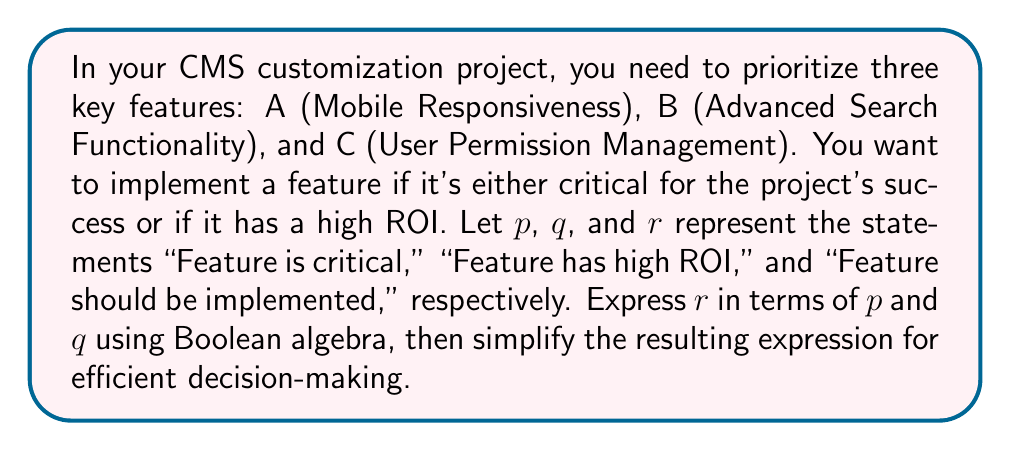Show me your answer to this math problem. Let's approach this step-by-step:

1) First, we need to express the condition for implementing a feature in logical terms:
   A feature should be implemented if it's critical OR if it has high ROI.
   In Boolean algebra, this can be written as:

   $r = p \lor q$

2) Now, we need to apply this condition to all three features. Let's use subscripts to differentiate:

   $r_A = p_A \lor q_A$
   $r_B = p_B \lor q_B$
   $r_C = p_C \lor q_C$

3) To make a decision about all features at once, we need to combine these expressions:

   $r = (p_A \lor q_A) \land (p_B \lor q_B) \land (p_C \lor q_C)$

4) This expression can be simplified using the distributive law of Boolean algebra:
   $(a \lor b) \land (c \lor d) = (a \land c) \lor (a \land d) \lor (b \land c) \lor (b \land d)$

   Applying this twice:

   $r = (p_A \land p_B \land p_C) \lor 
        (p_A \land p_B \land q_C) \lor 
        (p_A \land q_B \land p_C) \lor 
        (p_A \land q_B \land q_C) \lor 
        (q_A \land p_B \land p_C) \lor 
        (q_A \land p_B \land q_C) \lor 
        (q_A \land q_B \land p_C) \lor 
        (q_A \land q_B \land q_C)$

5) This simplified expression represents all possible combinations where features should be implemented. Each term in the disjunction (OR) represents a specific scenario where certain features are critical and others have high ROI.
Answer: $r = (p_A \land p_B \land p_C) \lor 
     (p_A \land p_B \land q_C) \lor 
     (p_A \land q_B \land p_C) \lor 
     (p_A \land q_B \land q_C) \lor 
     (q_A \land p_B \land p_C) \lor 
     (q_A \land p_B \land q_C) \lor 
     (q_A \land q_B \land p_C) \lor 
     (q_A \land q_B \land q_C)$ 